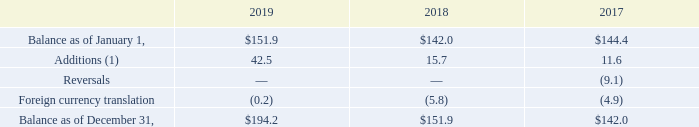AMERICAN TOWER CORPORATION AND SUBSIDIARIES NOTES TO CONSOLIDATED FINANCIAL STATEMENTS (Tabular amounts in millions, unless otherwise disclosed)
At December 31, 2019 and 2018, the Company has provided a valuation allowance of $194.2 million and $151.9 million, respectively, which primarily relates to foreign items. The increase in the valuation allowance for the year ending December 31, 2019 is due to uncertainty as to the timing of, and the Company’s ability to recover, net deferred tax assets in certain foreign operations in the foreseeable future, offset by fluctuations in foreign currency exchange rates. The amount of deferred tax assets considered realizable, however, could be adjusted if objective evidence in the form of cumulative losses is no longer present and additional weight may be given to subjective evidence such as the Company’s projections for growth.
A summary of the activity in the valuation allowance is as follows:
(1) Includes net charges to expense and allowances established due to acquisition.
The recoverability of the Company’s deferred tax assets has been assessed utilizing projections based on its current operations. Accordingly, the recoverability of the deferred tax assets is not dependent on material asset sales or other non-routine transactions. Based on its current outlook of future taxable income during the carryforward period, the Company believes that deferred tax assets, other than those for which a valuation allowance has been recorded, will be realized.
In which years did the company provide a valuation allowance? 2019, 2018. What was the valuation allowance provided by the company in 2018 and 2019 respectively? $151.9 million, $194.2 million. What were the additions in 2019?
Answer scale should be: million. 42.5. How many years was the balance as of January 1 above $100 million? 2019##2018##2017
Answer: 3. How many years was the balance as of December 31 above $150 million? 2019##2018
Answer: 2. What was the percentage change in Foreign currency translation between 2018 and 2019?
Answer scale should be: percent. (-0.2-(-5.8))/-5.8
Answer: -96.55. 